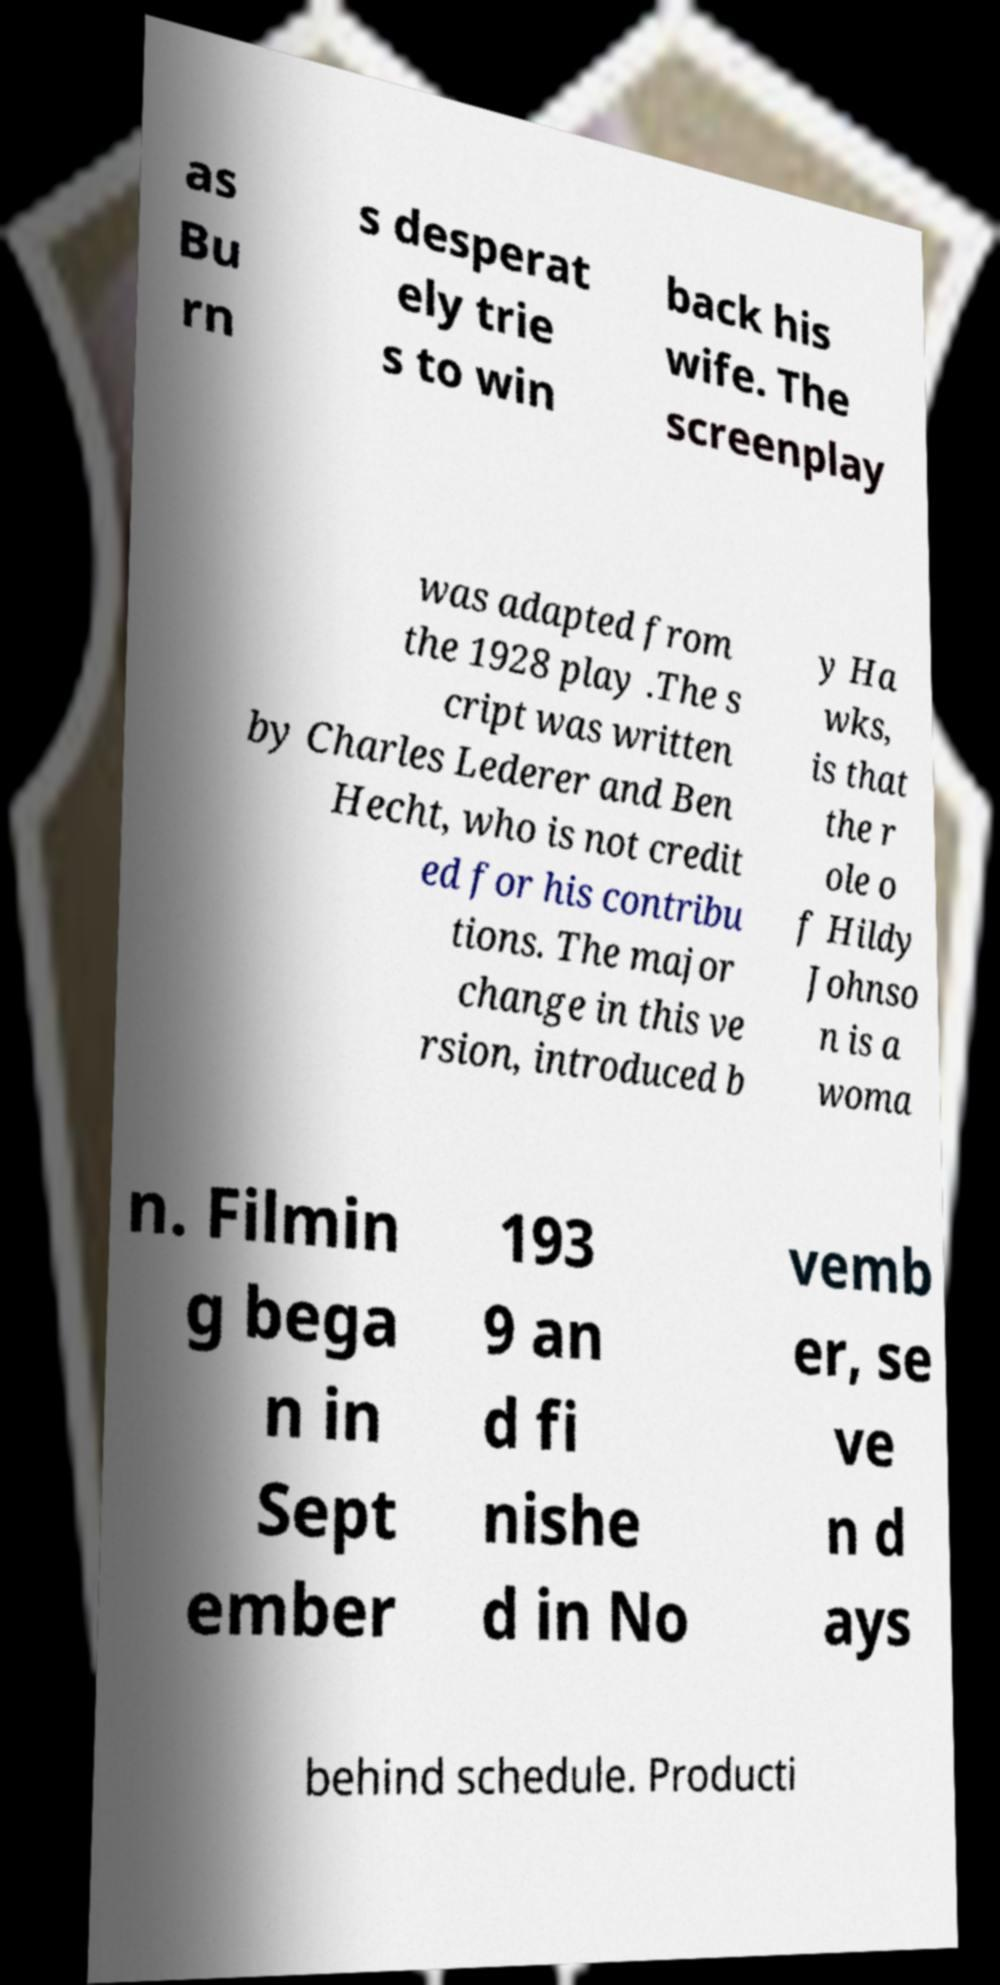For documentation purposes, I need the text within this image transcribed. Could you provide that? as Bu rn s desperat ely trie s to win back his wife. The screenplay was adapted from the 1928 play .The s cript was written by Charles Lederer and Ben Hecht, who is not credit ed for his contribu tions. The major change in this ve rsion, introduced b y Ha wks, is that the r ole o f Hildy Johnso n is a woma n. Filmin g bega n in Sept ember 193 9 an d fi nishe d in No vemb er, se ve n d ays behind schedule. Producti 